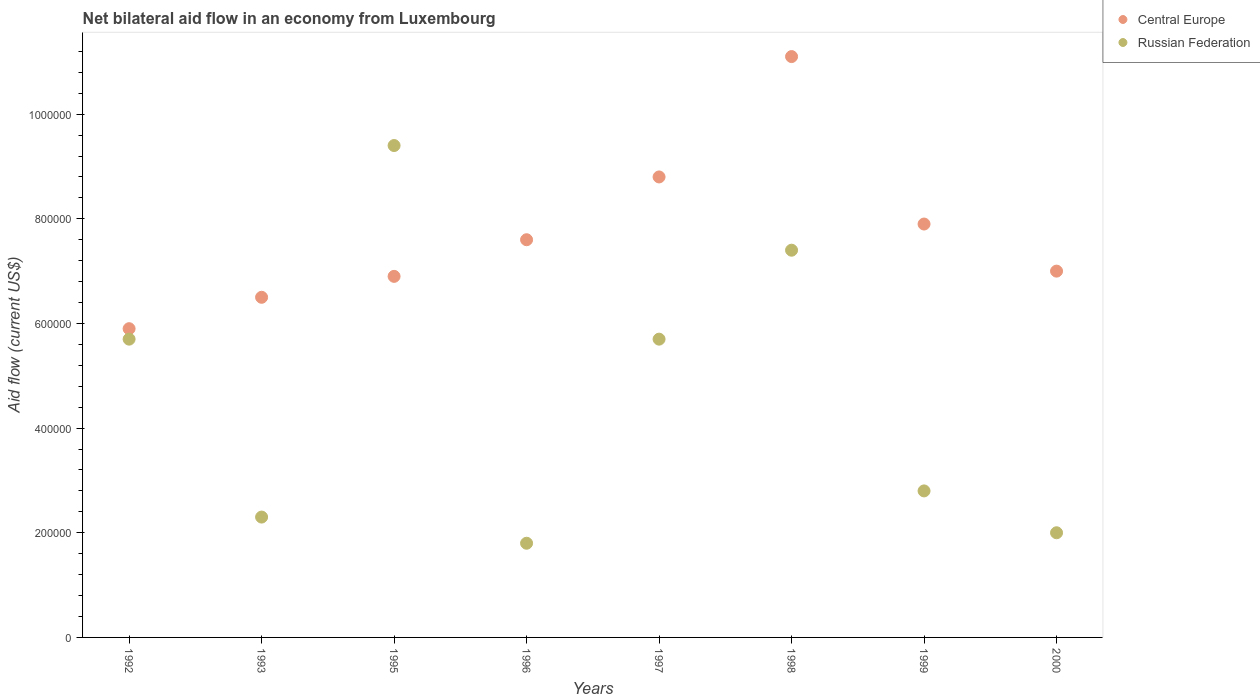Is the number of dotlines equal to the number of legend labels?
Provide a succinct answer. Yes. What is the net bilateral aid flow in Russian Federation in 1995?
Keep it short and to the point. 9.40e+05. Across all years, what is the maximum net bilateral aid flow in Russian Federation?
Your response must be concise. 9.40e+05. Across all years, what is the minimum net bilateral aid flow in Russian Federation?
Your answer should be compact. 1.80e+05. In which year was the net bilateral aid flow in Russian Federation minimum?
Your answer should be compact. 1996. What is the total net bilateral aid flow in Russian Federation in the graph?
Your answer should be compact. 3.71e+06. What is the difference between the net bilateral aid flow in Central Europe in 2000 and the net bilateral aid flow in Russian Federation in 1996?
Give a very brief answer. 5.20e+05. What is the average net bilateral aid flow in Russian Federation per year?
Make the answer very short. 4.64e+05. In the year 1995, what is the difference between the net bilateral aid flow in Russian Federation and net bilateral aid flow in Central Europe?
Your answer should be very brief. 2.50e+05. In how many years, is the net bilateral aid flow in Central Europe greater than 200000 US$?
Ensure brevity in your answer.  8. What is the ratio of the net bilateral aid flow in Russian Federation in 1993 to that in 1997?
Your response must be concise. 0.4. Is the net bilateral aid flow in Russian Federation in 1995 less than that in 1998?
Keep it short and to the point. No. Is the difference between the net bilateral aid flow in Russian Federation in 1997 and 1999 greater than the difference between the net bilateral aid flow in Central Europe in 1997 and 1999?
Provide a succinct answer. Yes. What is the difference between the highest and the lowest net bilateral aid flow in Russian Federation?
Offer a very short reply. 7.60e+05. Is the sum of the net bilateral aid flow in Russian Federation in 1996 and 1999 greater than the maximum net bilateral aid flow in Central Europe across all years?
Offer a terse response. No. Is the net bilateral aid flow in Central Europe strictly greater than the net bilateral aid flow in Russian Federation over the years?
Give a very brief answer. No. Are the values on the major ticks of Y-axis written in scientific E-notation?
Make the answer very short. No. Does the graph contain any zero values?
Keep it short and to the point. No. Does the graph contain grids?
Provide a short and direct response. No. How are the legend labels stacked?
Your answer should be compact. Vertical. What is the title of the graph?
Give a very brief answer. Net bilateral aid flow in an economy from Luxembourg. Does "Samoa" appear as one of the legend labels in the graph?
Give a very brief answer. No. What is the label or title of the Y-axis?
Your response must be concise. Aid flow (current US$). What is the Aid flow (current US$) in Central Europe in 1992?
Ensure brevity in your answer.  5.90e+05. What is the Aid flow (current US$) of Russian Federation in 1992?
Keep it short and to the point. 5.70e+05. What is the Aid flow (current US$) of Central Europe in 1993?
Provide a succinct answer. 6.50e+05. What is the Aid flow (current US$) of Central Europe in 1995?
Offer a very short reply. 6.90e+05. What is the Aid flow (current US$) in Russian Federation in 1995?
Keep it short and to the point. 9.40e+05. What is the Aid flow (current US$) of Central Europe in 1996?
Your response must be concise. 7.60e+05. What is the Aid flow (current US$) in Russian Federation in 1996?
Ensure brevity in your answer.  1.80e+05. What is the Aid flow (current US$) of Central Europe in 1997?
Your answer should be compact. 8.80e+05. What is the Aid flow (current US$) of Russian Federation in 1997?
Your answer should be compact. 5.70e+05. What is the Aid flow (current US$) in Central Europe in 1998?
Your answer should be very brief. 1.11e+06. What is the Aid flow (current US$) of Russian Federation in 1998?
Your answer should be compact. 7.40e+05. What is the Aid flow (current US$) of Central Europe in 1999?
Provide a short and direct response. 7.90e+05. What is the Aid flow (current US$) in Russian Federation in 1999?
Provide a succinct answer. 2.80e+05. Across all years, what is the maximum Aid flow (current US$) in Central Europe?
Ensure brevity in your answer.  1.11e+06. Across all years, what is the maximum Aid flow (current US$) of Russian Federation?
Ensure brevity in your answer.  9.40e+05. Across all years, what is the minimum Aid flow (current US$) of Central Europe?
Keep it short and to the point. 5.90e+05. Across all years, what is the minimum Aid flow (current US$) of Russian Federation?
Your answer should be compact. 1.80e+05. What is the total Aid flow (current US$) of Central Europe in the graph?
Your response must be concise. 6.17e+06. What is the total Aid flow (current US$) of Russian Federation in the graph?
Your answer should be very brief. 3.71e+06. What is the difference between the Aid flow (current US$) in Russian Federation in 1992 and that in 1995?
Offer a terse response. -3.70e+05. What is the difference between the Aid flow (current US$) of Russian Federation in 1992 and that in 1997?
Your answer should be very brief. 0. What is the difference between the Aid flow (current US$) of Central Europe in 1992 and that in 1998?
Make the answer very short. -5.20e+05. What is the difference between the Aid flow (current US$) in Russian Federation in 1992 and that in 1998?
Provide a succinct answer. -1.70e+05. What is the difference between the Aid flow (current US$) in Central Europe in 1992 and that in 1999?
Your response must be concise. -2.00e+05. What is the difference between the Aid flow (current US$) in Russian Federation in 1992 and that in 1999?
Your answer should be very brief. 2.90e+05. What is the difference between the Aid flow (current US$) of Central Europe in 1993 and that in 1995?
Make the answer very short. -4.00e+04. What is the difference between the Aid flow (current US$) in Russian Federation in 1993 and that in 1995?
Offer a terse response. -7.10e+05. What is the difference between the Aid flow (current US$) in Central Europe in 1993 and that in 1996?
Ensure brevity in your answer.  -1.10e+05. What is the difference between the Aid flow (current US$) of Central Europe in 1993 and that in 1998?
Provide a succinct answer. -4.60e+05. What is the difference between the Aid flow (current US$) in Russian Federation in 1993 and that in 1998?
Your answer should be compact. -5.10e+05. What is the difference between the Aid flow (current US$) in Central Europe in 1993 and that in 1999?
Offer a very short reply. -1.40e+05. What is the difference between the Aid flow (current US$) in Russian Federation in 1993 and that in 1999?
Ensure brevity in your answer.  -5.00e+04. What is the difference between the Aid flow (current US$) of Central Europe in 1995 and that in 1996?
Your answer should be compact. -7.00e+04. What is the difference between the Aid flow (current US$) in Russian Federation in 1995 and that in 1996?
Provide a short and direct response. 7.60e+05. What is the difference between the Aid flow (current US$) in Russian Federation in 1995 and that in 1997?
Ensure brevity in your answer.  3.70e+05. What is the difference between the Aid flow (current US$) of Central Europe in 1995 and that in 1998?
Ensure brevity in your answer.  -4.20e+05. What is the difference between the Aid flow (current US$) in Russian Federation in 1995 and that in 1999?
Offer a terse response. 6.60e+05. What is the difference between the Aid flow (current US$) of Russian Federation in 1995 and that in 2000?
Your answer should be very brief. 7.40e+05. What is the difference between the Aid flow (current US$) of Central Europe in 1996 and that in 1997?
Offer a very short reply. -1.20e+05. What is the difference between the Aid flow (current US$) of Russian Federation in 1996 and that in 1997?
Give a very brief answer. -3.90e+05. What is the difference between the Aid flow (current US$) in Central Europe in 1996 and that in 1998?
Offer a terse response. -3.50e+05. What is the difference between the Aid flow (current US$) of Russian Federation in 1996 and that in 1998?
Your answer should be compact. -5.60e+05. What is the difference between the Aid flow (current US$) of Central Europe in 1996 and that in 1999?
Keep it short and to the point. -3.00e+04. What is the difference between the Aid flow (current US$) of Russian Federation in 1997 and that in 1999?
Ensure brevity in your answer.  2.90e+05. What is the difference between the Aid flow (current US$) of Central Europe in 1997 and that in 2000?
Keep it short and to the point. 1.80e+05. What is the difference between the Aid flow (current US$) of Russian Federation in 1997 and that in 2000?
Offer a very short reply. 3.70e+05. What is the difference between the Aid flow (current US$) in Russian Federation in 1998 and that in 2000?
Provide a succinct answer. 5.40e+05. What is the difference between the Aid flow (current US$) of Russian Federation in 1999 and that in 2000?
Provide a succinct answer. 8.00e+04. What is the difference between the Aid flow (current US$) in Central Europe in 1992 and the Aid flow (current US$) in Russian Federation in 1993?
Provide a short and direct response. 3.60e+05. What is the difference between the Aid flow (current US$) of Central Europe in 1992 and the Aid flow (current US$) of Russian Federation in 1995?
Offer a very short reply. -3.50e+05. What is the difference between the Aid flow (current US$) of Central Europe in 1992 and the Aid flow (current US$) of Russian Federation in 1996?
Keep it short and to the point. 4.10e+05. What is the difference between the Aid flow (current US$) of Central Europe in 1992 and the Aid flow (current US$) of Russian Federation in 1998?
Your response must be concise. -1.50e+05. What is the difference between the Aid flow (current US$) of Central Europe in 1992 and the Aid flow (current US$) of Russian Federation in 2000?
Your answer should be compact. 3.90e+05. What is the difference between the Aid flow (current US$) in Central Europe in 1993 and the Aid flow (current US$) in Russian Federation in 1995?
Offer a terse response. -2.90e+05. What is the difference between the Aid flow (current US$) in Central Europe in 1993 and the Aid flow (current US$) in Russian Federation in 1997?
Your answer should be very brief. 8.00e+04. What is the difference between the Aid flow (current US$) of Central Europe in 1993 and the Aid flow (current US$) of Russian Federation in 1998?
Provide a short and direct response. -9.00e+04. What is the difference between the Aid flow (current US$) in Central Europe in 1993 and the Aid flow (current US$) in Russian Federation in 2000?
Your answer should be very brief. 4.50e+05. What is the difference between the Aid flow (current US$) of Central Europe in 1995 and the Aid flow (current US$) of Russian Federation in 1996?
Your answer should be very brief. 5.10e+05. What is the difference between the Aid flow (current US$) of Central Europe in 1995 and the Aid flow (current US$) of Russian Federation in 1997?
Offer a very short reply. 1.20e+05. What is the difference between the Aid flow (current US$) in Central Europe in 1996 and the Aid flow (current US$) in Russian Federation in 1998?
Your answer should be compact. 2.00e+04. What is the difference between the Aid flow (current US$) in Central Europe in 1996 and the Aid flow (current US$) in Russian Federation in 1999?
Provide a short and direct response. 4.80e+05. What is the difference between the Aid flow (current US$) of Central Europe in 1996 and the Aid flow (current US$) of Russian Federation in 2000?
Offer a terse response. 5.60e+05. What is the difference between the Aid flow (current US$) of Central Europe in 1997 and the Aid flow (current US$) of Russian Federation in 1998?
Your answer should be very brief. 1.40e+05. What is the difference between the Aid flow (current US$) of Central Europe in 1997 and the Aid flow (current US$) of Russian Federation in 1999?
Keep it short and to the point. 6.00e+05. What is the difference between the Aid flow (current US$) of Central Europe in 1997 and the Aid flow (current US$) of Russian Federation in 2000?
Your response must be concise. 6.80e+05. What is the difference between the Aid flow (current US$) in Central Europe in 1998 and the Aid flow (current US$) in Russian Federation in 1999?
Provide a short and direct response. 8.30e+05. What is the difference between the Aid flow (current US$) of Central Europe in 1998 and the Aid flow (current US$) of Russian Federation in 2000?
Provide a succinct answer. 9.10e+05. What is the difference between the Aid flow (current US$) in Central Europe in 1999 and the Aid flow (current US$) in Russian Federation in 2000?
Keep it short and to the point. 5.90e+05. What is the average Aid flow (current US$) of Central Europe per year?
Give a very brief answer. 7.71e+05. What is the average Aid flow (current US$) in Russian Federation per year?
Your response must be concise. 4.64e+05. In the year 1995, what is the difference between the Aid flow (current US$) of Central Europe and Aid flow (current US$) of Russian Federation?
Your response must be concise. -2.50e+05. In the year 1996, what is the difference between the Aid flow (current US$) of Central Europe and Aid flow (current US$) of Russian Federation?
Your answer should be compact. 5.80e+05. In the year 1997, what is the difference between the Aid flow (current US$) of Central Europe and Aid flow (current US$) of Russian Federation?
Provide a succinct answer. 3.10e+05. In the year 1999, what is the difference between the Aid flow (current US$) of Central Europe and Aid flow (current US$) of Russian Federation?
Make the answer very short. 5.10e+05. What is the ratio of the Aid flow (current US$) in Central Europe in 1992 to that in 1993?
Provide a short and direct response. 0.91. What is the ratio of the Aid flow (current US$) of Russian Federation in 1992 to that in 1993?
Make the answer very short. 2.48. What is the ratio of the Aid flow (current US$) of Central Europe in 1992 to that in 1995?
Provide a short and direct response. 0.86. What is the ratio of the Aid flow (current US$) of Russian Federation in 1992 to that in 1995?
Your answer should be very brief. 0.61. What is the ratio of the Aid flow (current US$) in Central Europe in 1992 to that in 1996?
Offer a terse response. 0.78. What is the ratio of the Aid flow (current US$) of Russian Federation in 1992 to that in 1996?
Ensure brevity in your answer.  3.17. What is the ratio of the Aid flow (current US$) in Central Europe in 1992 to that in 1997?
Your answer should be compact. 0.67. What is the ratio of the Aid flow (current US$) of Russian Federation in 1992 to that in 1997?
Give a very brief answer. 1. What is the ratio of the Aid flow (current US$) in Central Europe in 1992 to that in 1998?
Your answer should be compact. 0.53. What is the ratio of the Aid flow (current US$) of Russian Federation in 1992 to that in 1998?
Your response must be concise. 0.77. What is the ratio of the Aid flow (current US$) in Central Europe in 1992 to that in 1999?
Your response must be concise. 0.75. What is the ratio of the Aid flow (current US$) in Russian Federation in 1992 to that in 1999?
Give a very brief answer. 2.04. What is the ratio of the Aid flow (current US$) of Central Europe in 1992 to that in 2000?
Your response must be concise. 0.84. What is the ratio of the Aid flow (current US$) in Russian Federation in 1992 to that in 2000?
Ensure brevity in your answer.  2.85. What is the ratio of the Aid flow (current US$) of Central Europe in 1993 to that in 1995?
Your response must be concise. 0.94. What is the ratio of the Aid flow (current US$) in Russian Federation in 1993 to that in 1995?
Offer a very short reply. 0.24. What is the ratio of the Aid flow (current US$) in Central Europe in 1993 to that in 1996?
Make the answer very short. 0.86. What is the ratio of the Aid flow (current US$) in Russian Federation in 1993 to that in 1996?
Ensure brevity in your answer.  1.28. What is the ratio of the Aid flow (current US$) of Central Europe in 1993 to that in 1997?
Offer a terse response. 0.74. What is the ratio of the Aid flow (current US$) of Russian Federation in 1993 to that in 1997?
Your response must be concise. 0.4. What is the ratio of the Aid flow (current US$) of Central Europe in 1993 to that in 1998?
Your answer should be compact. 0.59. What is the ratio of the Aid flow (current US$) of Russian Federation in 1993 to that in 1998?
Provide a short and direct response. 0.31. What is the ratio of the Aid flow (current US$) of Central Europe in 1993 to that in 1999?
Make the answer very short. 0.82. What is the ratio of the Aid flow (current US$) in Russian Federation in 1993 to that in 1999?
Make the answer very short. 0.82. What is the ratio of the Aid flow (current US$) in Russian Federation in 1993 to that in 2000?
Provide a succinct answer. 1.15. What is the ratio of the Aid flow (current US$) of Central Europe in 1995 to that in 1996?
Keep it short and to the point. 0.91. What is the ratio of the Aid flow (current US$) of Russian Federation in 1995 to that in 1996?
Your response must be concise. 5.22. What is the ratio of the Aid flow (current US$) in Central Europe in 1995 to that in 1997?
Give a very brief answer. 0.78. What is the ratio of the Aid flow (current US$) in Russian Federation in 1995 to that in 1997?
Offer a terse response. 1.65. What is the ratio of the Aid flow (current US$) of Central Europe in 1995 to that in 1998?
Ensure brevity in your answer.  0.62. What is the ratio of the Aid flow (current US$) of Russian Federation in 1995 to that in 1998?
Keep it short and to the point. 1.27. What is the ratio of the Aid flow (current US$) of Central Europe in 1995 to that in 1999?
Provide a succinct answer. 0.87. What is the ratio of the Aid flow (current US$) of Russian Federation in 1995 to that in 1999?
Ensure brevity in your answer.  3.36. What is the ratio of the Aid flow (current US$) in Central Europe in 1995 to that in 2000?
Offer a terse response. 0.99. What is the ratio of the Aid flow (current US$) of Central Europe in 1996 to that in 1997?
Keep it short and to the point. 0.86. What is the ratio of the Aid flow (current US$) of Russian Federation in 1996 to that in 1997?
Provide a short and direct response. 0.32. What is the ratio of the Aid flow (current US$) in Central Europe in 1996 to that in 1998?
Provide a succinct answer. 0.68. What is the ratio of the Aid flow (current US$) of Russian Federation in 1996 to that in 1998?
Give a very brief answer. 0.24. What is the ratio of the Aid flow (current US$) of Central Europe in 1996 to that in 1999?
Your response must be concise. 0.96. What is the ratio of the Aid flow (current US$) in Russian Federation in 1996 to that in 1999?
Your response must be concise. 0.64. What is the ratio of the Aid flow (current US$) of Central Europe in 1996 to that in 2000?
Offer a very short reply. 1.09. What is the ratio of the Aid flow (current US$) of Russian Federation in 1996 to that in 2000?
Provide a succinct answer. 0.9. What is the ratio of the Aid flow (current US$) of Central Europe in 1997 to that in 1998?
Ensure brevity in your answer.  0.79. What is the ratio of the Aid flow (current US$) in Russian Federation in 1997 to that in 1998?
Ensure brevity in your answer.  0.77. What is the ratio of the Aid flow (current US$) in Central Europe in 1997 to that in 1999?
Your answer should be very brief. 1.11. What is the ratio of the Aid flow (current US$) of Russian Federation in 1997 to that in 1999?
Your answer should be very brief. 2.04. What is the ratio of the Aid flow (current US$) in Central Europe in 1997 to that in 2000?
Provide a short and direct response. 1.26. What is the ratio of the Aid flow (current US$) of Russian Federation in 1997 to that in 2000?
Ensure brevity in your answer.  2.85. What is the ratio of the Aid flow (current US$) of Central Europe in 1998 to that in 1999?
Offer a terse response. 1.41. What is the ratio of the Aid flow (current US$) of Russian Federation in 1998 to that in 1999?
Provide a succinct answer. 2.64. What is the ratio of the Aid flow (current US$) of Central Europe in 1998 to that in 2000?
Keep it short and to the point. 1.59. What is the ratio of the Aid flow (current US$) of Central Europe in 1999 to that in 2000?
Provide a succinct answer. 1.13. What is the difference between the highest and the second highest Aid flow (current US$) of Central Europe?
Give a very brief answer. 2.30e+05. What is the difference between the highest and the second highest Aid flow (current US$) of Russian Federation?
Keep it short and to the point. 2.00e+05. What is the difference between the highest and the lowest Aid flow (current US$) of Central Europe?
Offer a terse response. 5.20e+05. What is the difference between the highest and the lowest Aid flow (current US$) of Russian Federation?
Offer a terse response. 7.60e+05. 